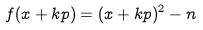<formula> <loc_0><loc_0><loc_500><loc_500>f ( x + k p ) = ( x + k p ) ^ { 2 } - n</formula> 